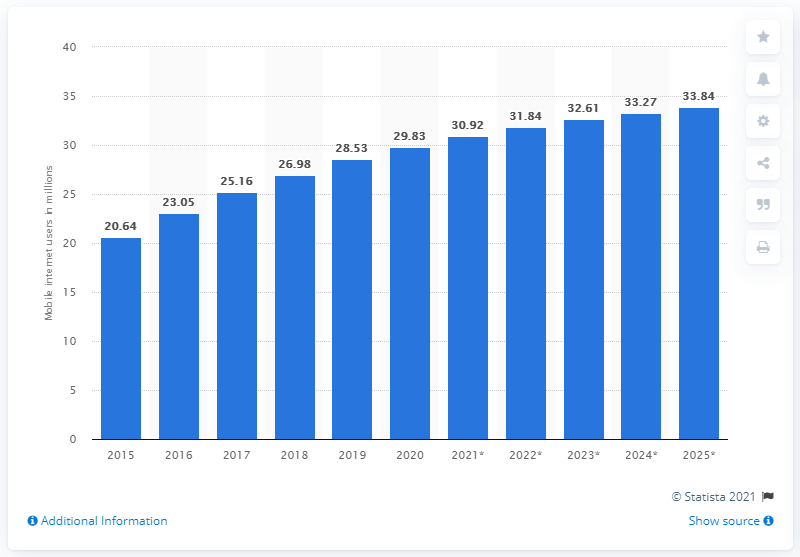Point out several critical features in this image. As of 2020, there were 29.83 million mobile internet users in Canada. By 2025, it is projected that there will be 33.84 mobile internet users in Canada. 